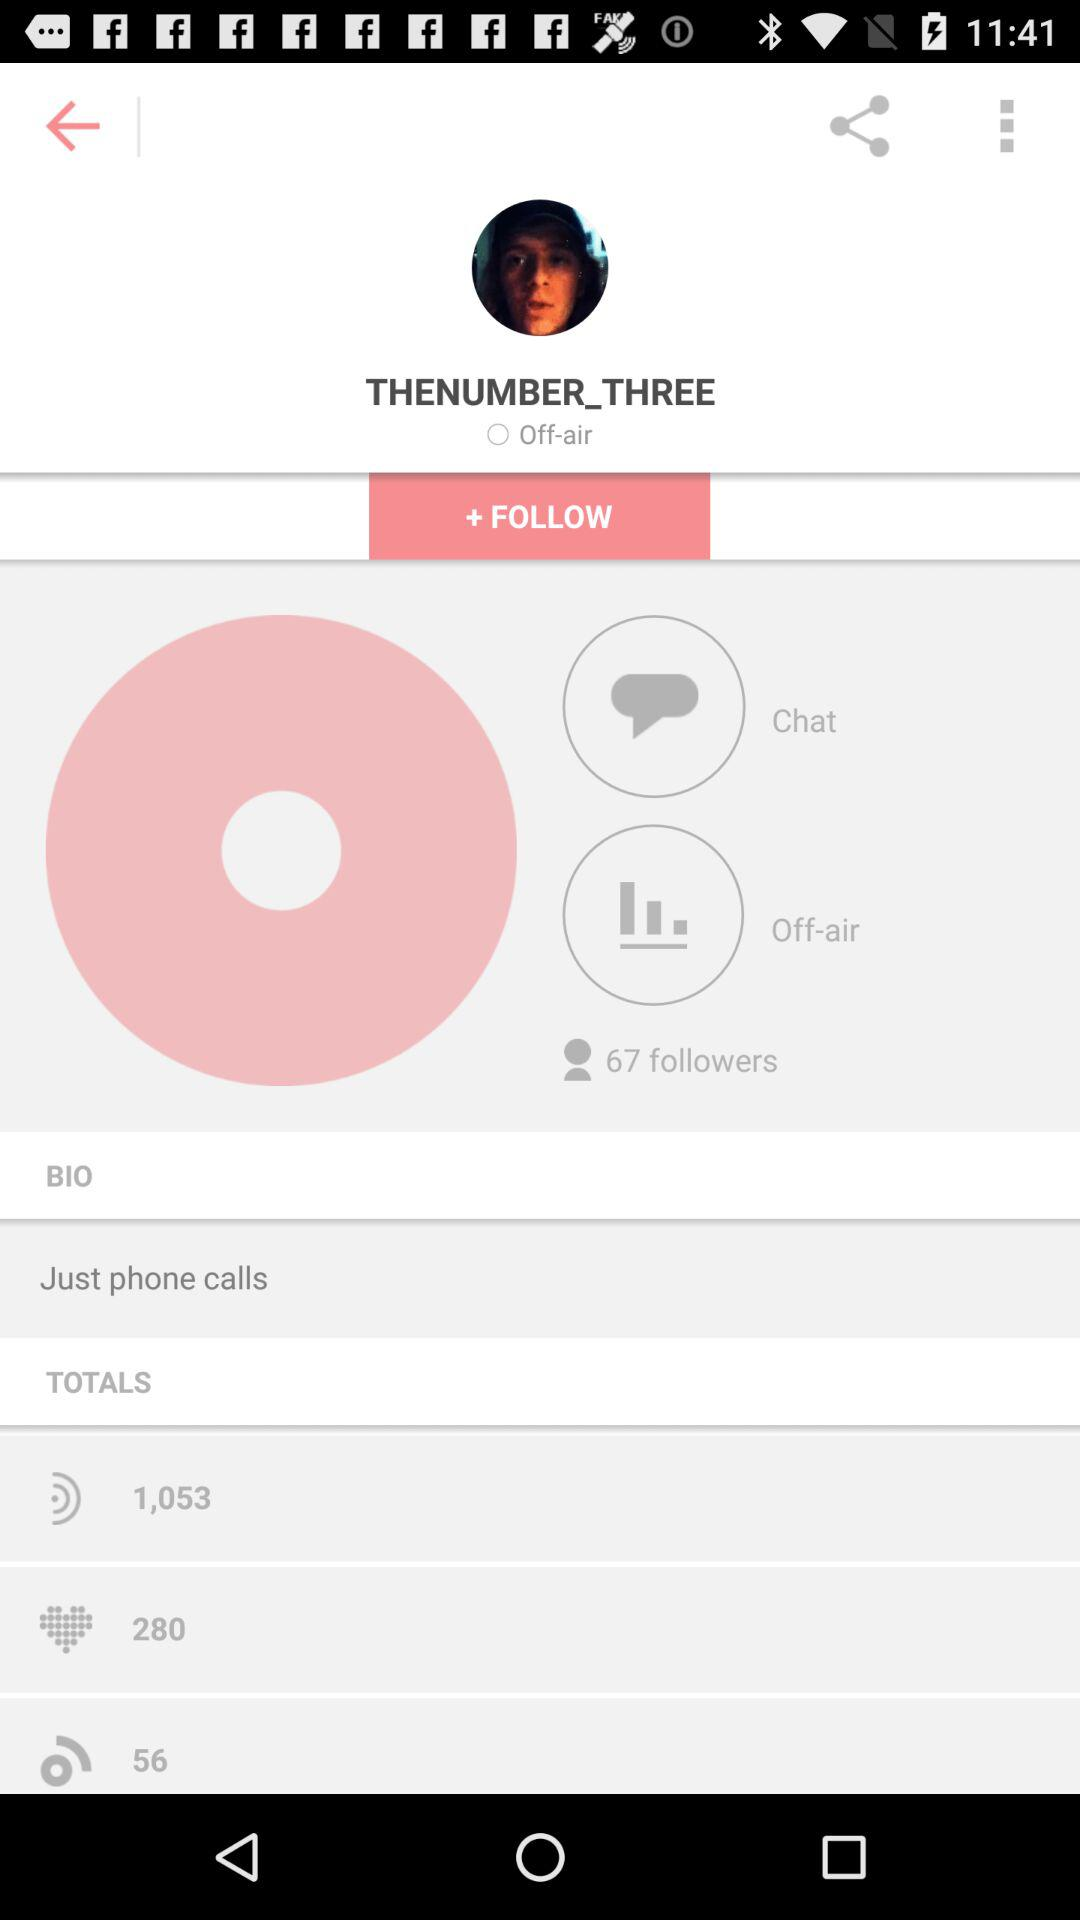How many followers does this person have?
Answer the question using a single word or phrase. 67 